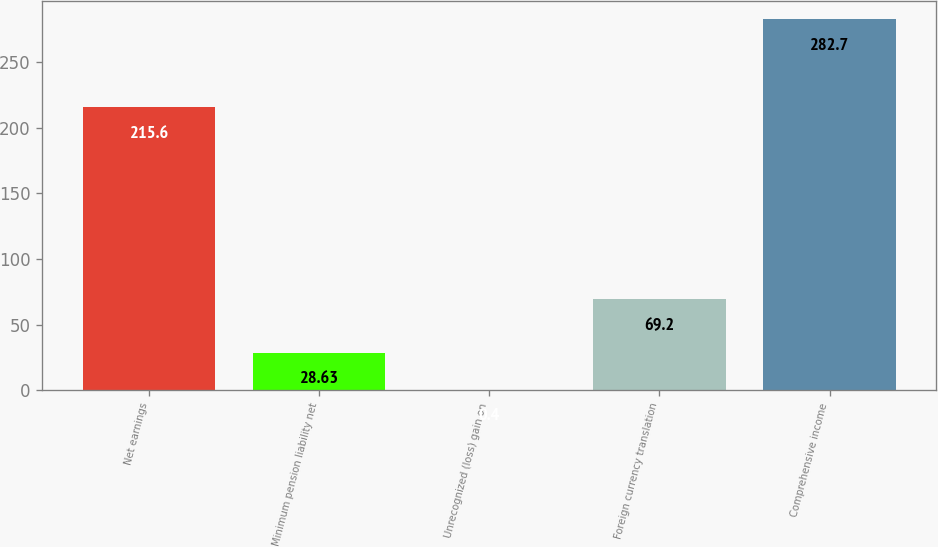<chart> <loc_0><loc_0><loc_500><loc_500><bar_chart><fcel>Net earnings<fcel>Minimum pension liability net<fcel>Unrecognized (loss) gain on<fcel>Foreign currency translation<fcel>Comprehensive income<nl><fcel>215.6<fcel>28.63<fcel>0.4<fcel>69.2<fcel>282.7<nl></chart> 